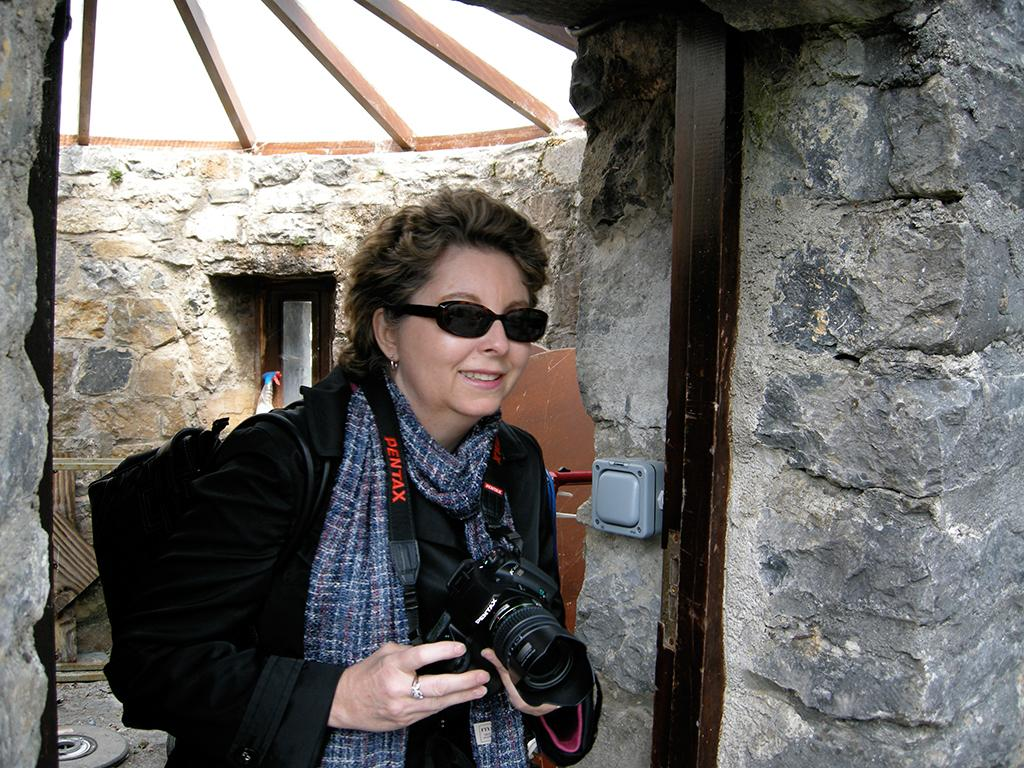What is the woman holding in her hand in the image? The woman is holding a camera in her hand. What is the woman wearing on her face in the image? The woman is wearing sunglasses in the image. What type of pump is the woman using to take pictures in the image? There is no pump present in the image; the woman is holding a camera. --- Transcript: In this image we can see a person sitting on a chair and reading a book. There is a table in front of the person with a cup of coffee on it. Facts: 1. There is a person in the image. 2. The person is sitting on a chair. 3. The person is reading a book. 4. There is a table in front of the person. 5. There is a cup of coffee on the table. Absurd Topics: dance, piano, bicycle Conversation: What is the person in the image doing? The person in the image is sitting on a chair and reading a book. What is on the table in front of the person? There is a cup of coffee on the table in front of the person. What might the person be doing after reading the book? It is not mentioned in the facts, but the person might take a sip of their coffee after reading the book. Reasoning: Let's think step by step in order to produce the conversation. We start by identifying the main subject in the image, which is the person. Then, we describe the person's actions based on the provided facts. We also mention the presence of the table and the cup of coffee on the table. Finally, we speculate about a possible action that the person might do after reading the book, although it is not mentioned in the facts, it is a reasonable assumption based on the context of the image. Absurd Question/Answer: What type of dance is the person performing while reading the book in the image? There is no indication of any dance performance in the image; the person is sitting on a chair and reading a book. --- Transcript: In this picture we can see a cat sitting on a table. There is a bowl of food and a glass of water on the table. Facts: 1. There is a cat in the image. 2. The cat is sitting on a table. 3. There is a bowl of food on the table. 4. There is a glass of water on the table. Absurd Topics: dog Conversation: What type of animal is in the image? In the image, there is a cat. What is the cat sitting on in the image? In the image, the cat is sitting on a table. What is on the table in the image? In the image, there is a bowl of food and a glass of water on the table. Reasoning: Let's think step by step in order to produce the conversation. We 